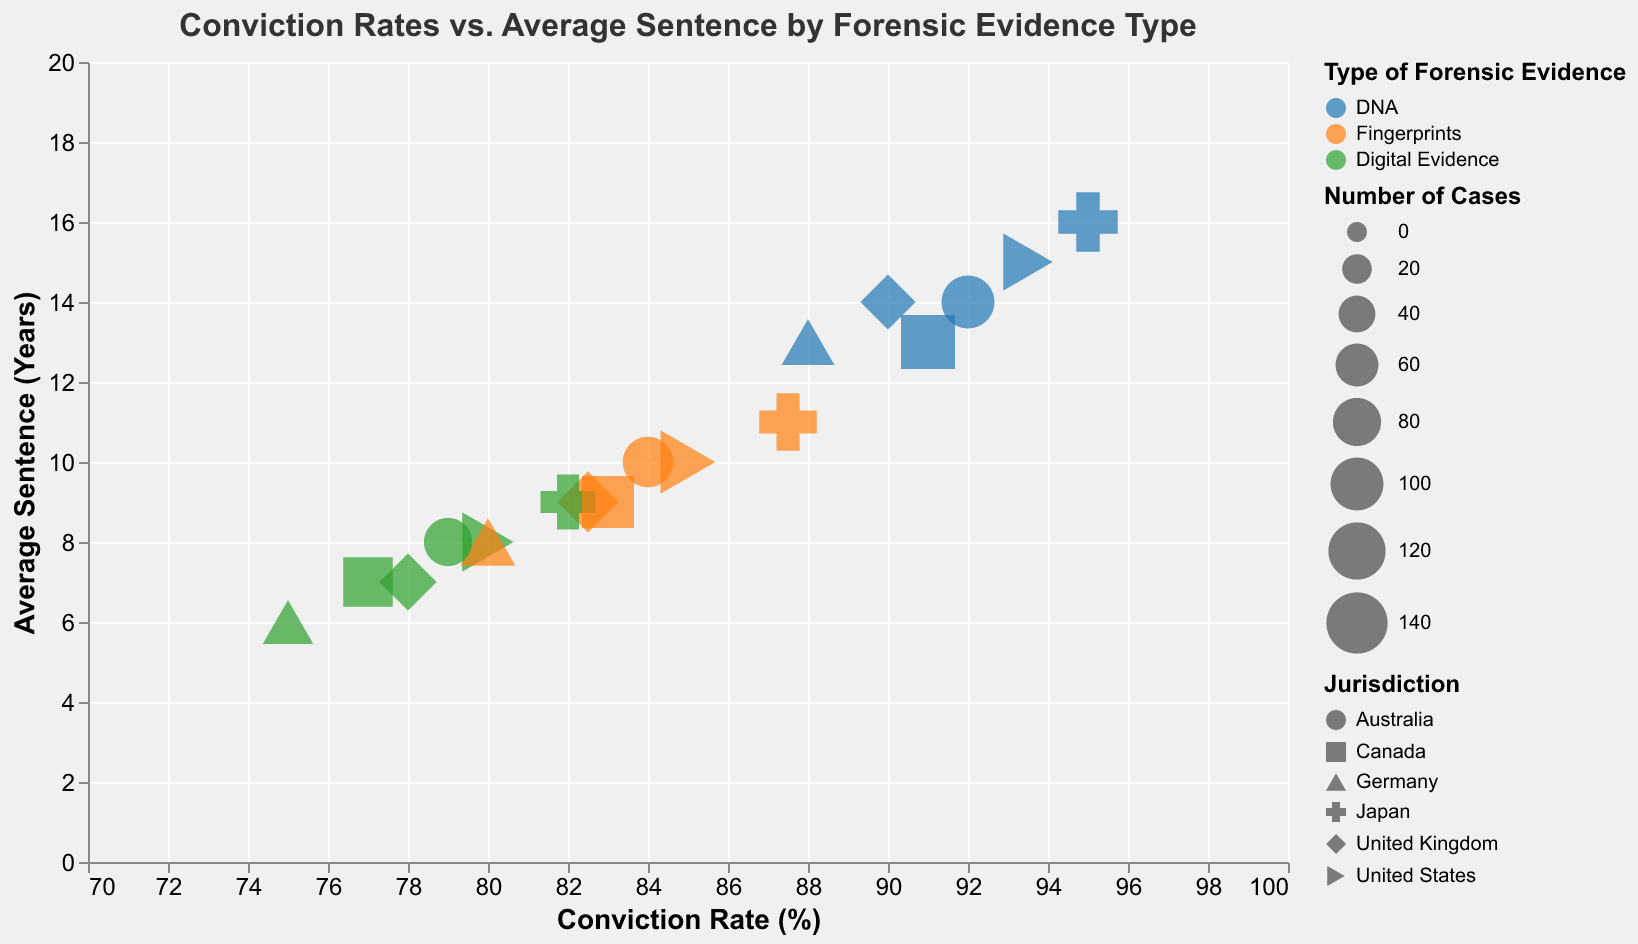What is the title of the chart? The title of the chart is displayed at the top of the figure. It reads "Conviction Rates vs. Average Sentence by Forensic Evidence Type".
Answer: Conviction Rates vs. Average Sentence by Forensic Evidence Type How is the size of a bubble determined? The size of a bubble is proportionate to the number of cases associated with that data point. Larger bubbles indicate a higher number of cases. This is visible from the size legend, labeled "Number of Cases".
Answer: Number of cases Which type of forensic evidence has the highest conviction rate in the chart? By examining the x-axis, the data point farthest to the right (highest conviction rate) is "DNA" evidence in Japan with a conviction rate of 95.0%.
Answer: DNA in Japan What is the average sentence for digital evidence in the United States? To find this, locate the bubble for "Digital Evidence" within the United States domain on the chart. The y-axis reveals the average sentence, which is 8 years.
Answer: 8 years Compare the average sentence for DNA evidence between Japan and Germany. Which is higher? By locating both "DNA" evidence points for Japan and Germany on the chart, comparing their positions on the y-axis reveals that Japan (16 years) has a higher average sentence than Germany (13 years).
Answer: Japan (16 years) Which jurisdiction has the largest number of cases using fingerprint evidence? The size of the bubble for "Fingerprints" in the United States is the largest among jurisdictions. The tooltip or legend confirms 150 cases.
Answer: United States (150 cases) What is the difference in conviction rates between the United Kingdom and Australia for fingerprint evidence? Identify the conviction rates for "Fingerprints" in both jurisdictions: the United Kingdom has 82.5% and Australia has 84.0%. The difference is 84.0% - 82.5% = 1.5%.
Answer: 1.5% Identify which type of forensic evidence typically yields the lowest average sentence across all jurisdictions. By examining the y-axis across all bubbles, "Digital Evidence" generally appears lower on the y-axis than other types, indicating a lower average sentence.
Answer: Digital Evidence What is the combined number of cases utilizing digital evidence for Germany and Canada? The chart shows the number of cases for "Digital Evidence" in Germany and Canada. Germany has 90 cases, and Canada has 85 cases. The sum is 90 + 85 = 175 cases.
Answer: 175 cases Which jurisdiction has the most balanced distribution of conviction rate and average sentence for fingerprint evidence? By analyzing the position for "Fingerprints" across jurisdictions, and finding the point closest to the middle of both axes, "Fingerprints" in Canada has a conviction rate of 83% and an average sentence of 9 years, balancing both measures.
Answer: Canada 